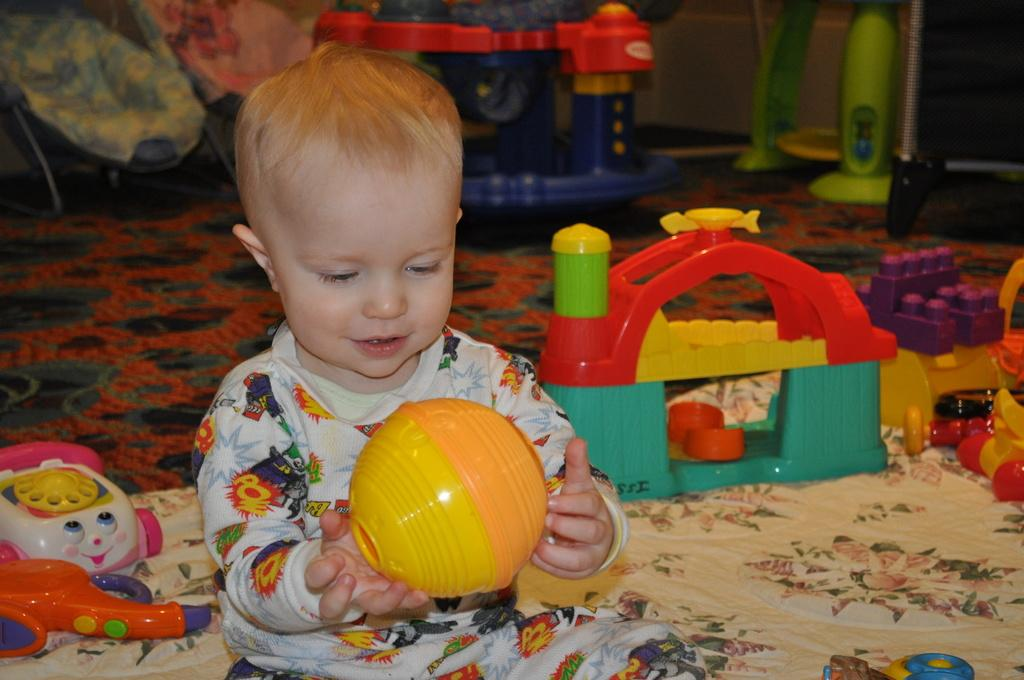Who is present in the image? There is a boy in the image. What is the boy holding in the image? The boy is holding an object. What else can be seen near the boy? There are toys beside the boy. What is at the bottom of the image? There is a mat at the bottom of the image. What can be seen in the background of the image? There are objects in the background of the image. What type of pies is the queen eating in the image? There is no queen or pies present in the image; it features a boy holding an object and toys beside him. 